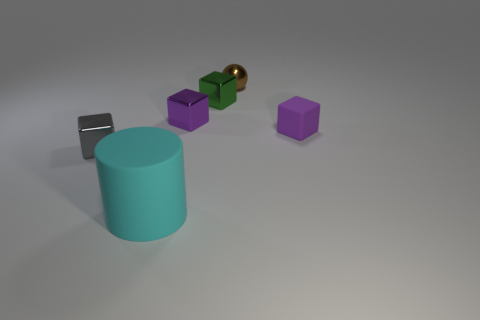Are there any other things that are the same size as the matte cylinder?
Keep it short and to the point. No. How big is the cyan object?
Keep it short and to the point. Large. What number of other things are the same color as the small rubber block?
Ensure brevity in your answer.  1. What number of other objects are there of the same material as the brown thing?
Your answer should be very brief. 3. There is a object that is both to the right of the tiny green cube and in front of the tiny brown metallic ball; what is its size?
Provide a short and direct response. Small. What is the shape of the tiny purple thing to the left of the metallic object behind the green metal thing?
Your answer should be compact. Cube. Is there any other thing that is the same shape as the big rubber object?
Your answer should be very brief. No. Is the number of big cyan objects that are behind the large matte thing the same as the number of small purple matte blocks?
Provide a short and direct response. No. There is a tiny thing that is both right of the green metallic block and in front of the sphere; what is its color?
Give a very brief answer. Purple. What number of small metallic objects are in front of the tiny purple thing that is to the left of the tiny matte object?
Provide a succinct answer. 1. 